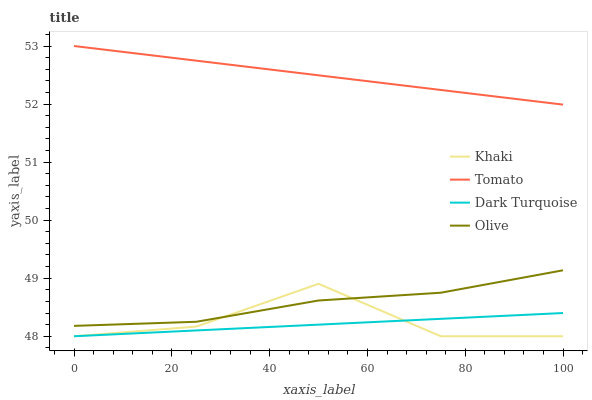Does Dark Turquoise have the minimum area under the curve?
Answer yes or no. Yes. Does Tomato have the maximum area under the curve?
Answer yes or no. Yes. Does Khaki have the minimum area under the curve?
Answer yes or no. No. Does Khaki have the maximum area under the curve?
Answer yes or no. No. Is Dark Turquoise the smoothest?
Answer yes or no. Yes. Is Khaki the roughest?
Answer yes or no. Yes. Is Khaki the smoothest?
Answer yes or no. No. Is Dark Turquoise the roughest?
Answer yes or no. No. Does Dark Turquoise have the lowest value?
Answer yes or no. Yes. Does Olive have the lowest value?
Answer yes or no. No. Does Tomato have the highest value?
Answer yes or no. Yes. Does Khaki have the highest value?
Answer yes or no. No. Is Dark Turquoise less than Olive?
Answer yes or no. Yes. Is Tomato greater than Khaki?
Answer yes or no. Yes. Does Khaki intersect Olive?
Answer yes or no. Yes. Is Khaki less than Olive?
Answer yes or no. No. Is Khaki greater than Olive?
Answer yes or no. No. Does Dark Turquoise intersect Olive?
Answer yes or no. No. 